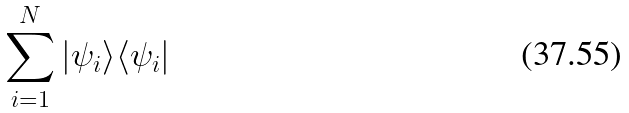Convert formula to latex. <formula><loc_0><loc_0><loc_500><loc_500>\sum _ { i = 1 } ^ { N } | \psi _ { i } \rangle \langle \psi _ { i } |</formula> 